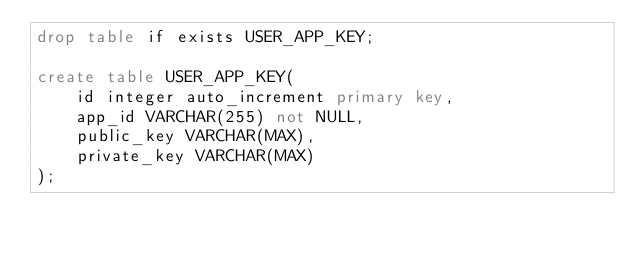<code> <loc_0><loc_0><loc_500><loc_500><_SQL_>drop table if exists USER_APP_KEY;

create table USER_APP_KEY(
	id integer auto_increment primary key,
	app_id VARCHAR(255) not NULL, 
	public_key VARCHAR(MAX), 
	private_key VARCHAR(MAX)
);
</code> 